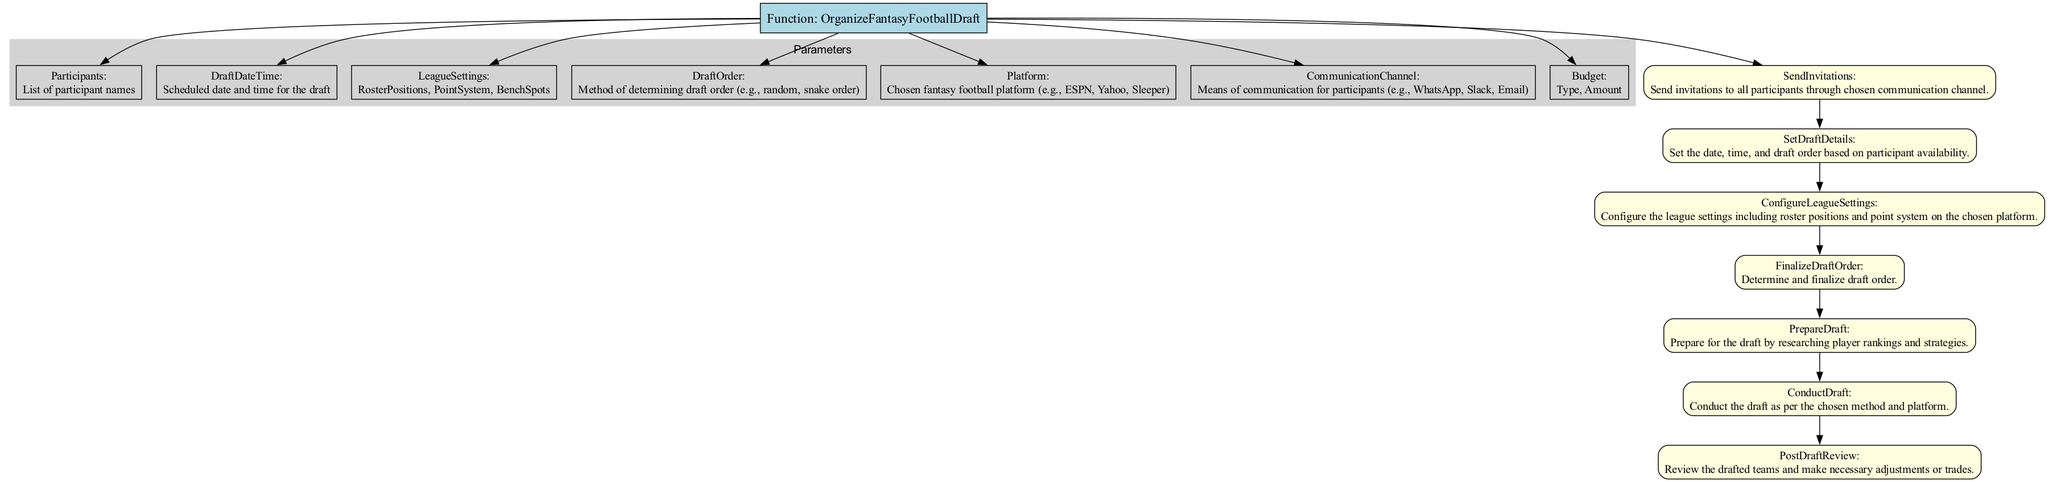What is the name of the main function? The main function is indicated at the top of the diagram, labeled as "Function: OrganizeFantasyFootballDraft". Hence, the name of the main function is derived directly from this label.
Answer: OrganizeFantasyFootballDraft How many parameters are there? The parameters are listed in a separate section within the diagram. Counting the nodes that represent these parameters indicates there are 7 parameters in total.
Answer: 7 What is the first step in the draft organization process? The steps are connected directly to the main function in sequential order. The first step is labeled "SendInvitations", which appears at the start of the steps section.
Answer: SendInvitations Which platform options are available? The diagram does not specify the exact options but indicates a node labeled "Platform" which informs about the chosen fantasy football platform. Hence, it implies that options should be specified without stating them directly in the diagram.
Answer: Chosen fantasy football platform What type of budget is needed if using auction draft? The budget type is specified within the "Budget" parameter where it indicates either "Auction or Standard". Therefore, if using auction, the answer leans towards "Auction".
Answer: Auction What comes after configuring league settings? The flowchart presents the steps in a sequential manner starting from league settings, leading directly to the next step labeled "FinalizeDraftOrder". This indicates that "FinalizeDraftOrder" comes directly after the previous step.
Answer: FinalizeDraftOrder What method is mentioned for determining draft order? Inside the parameters, there is a section labeled "DraftOrder", which mentions that it can be determined using various methods. Hence, the answer revolves around the instructions provided.
Answer: Method of determining draft order How many steps are there in total for organizing the draft? The "Steps" section lists multiple step nodes. Counting these nodes yields the precise number of steps in the organization process. There are 7 steps listed.
Answer: 7 What is the communication channel used for participant interaction? Within the parameters, there is a specific node labeled "CommunicationChannel", which suggests various means for communication, although not detailed in the text.
Answer: Means of communication for participants 